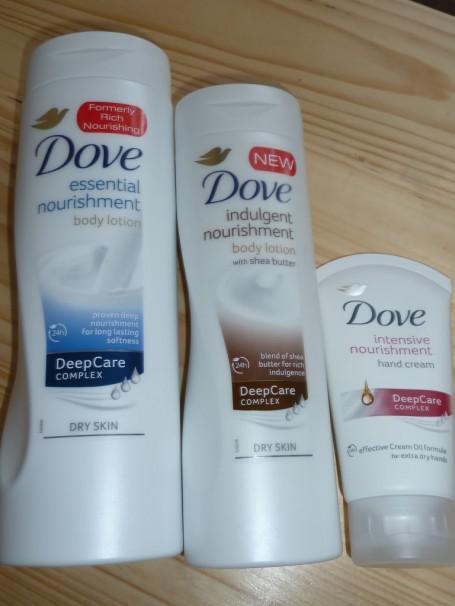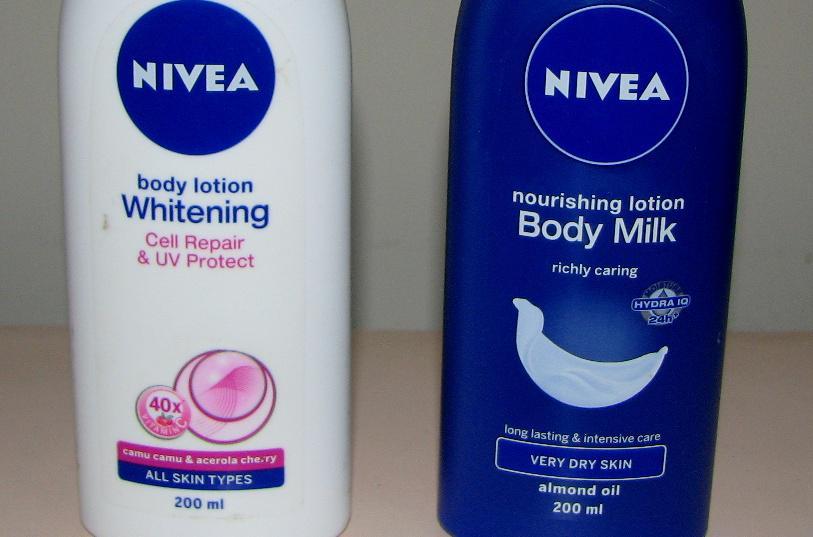The first image is the image on the left, the second image is the image on the right. Considering the images on both sides, is "The left image shows two containers labeled, """"Dove.""""" valid? Answer yes or no. No. The first image is the image on the left, the second image is the image on the right. For the images shown, is this caption "There is at least one product shown with its corresponding box." true? Answer yes or no. No. 